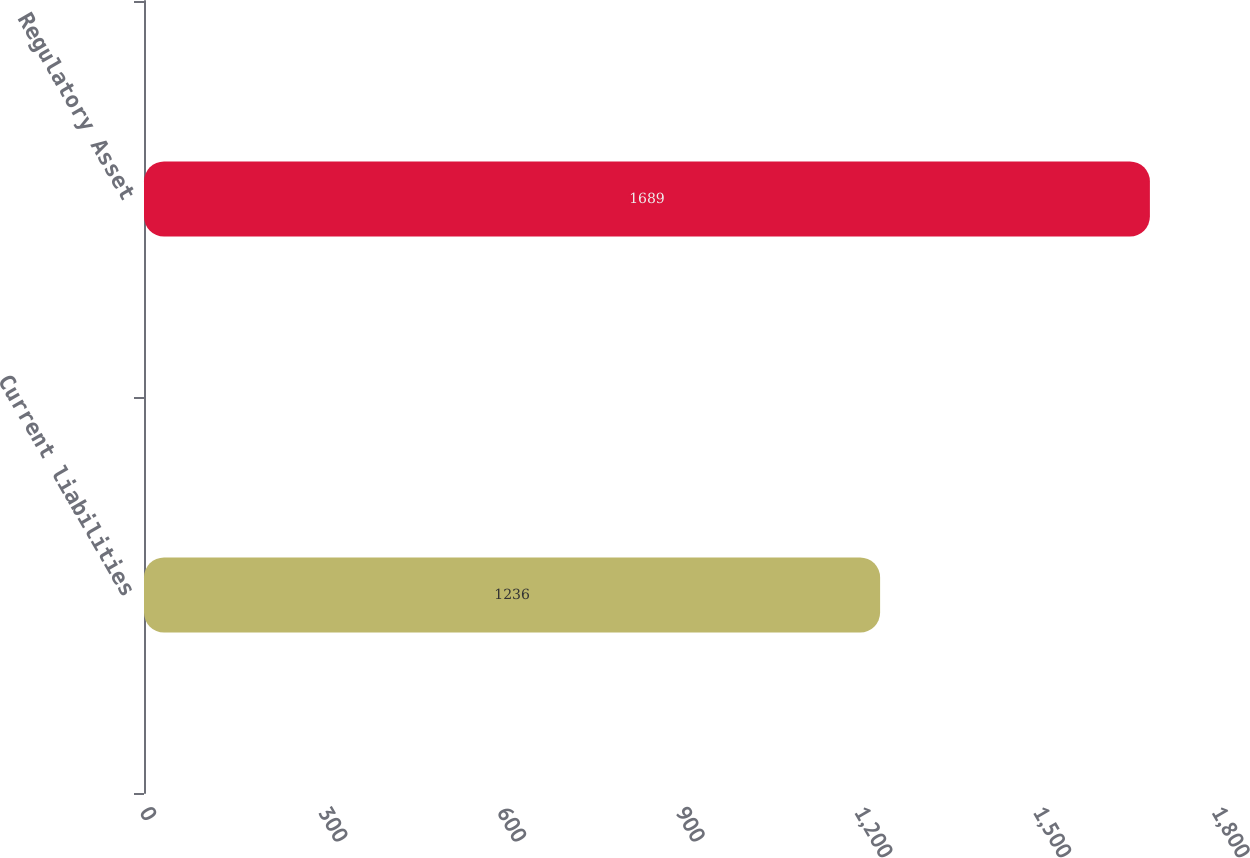Convert chart to OTSL. <chart><loc_0><loc_0><loc_500><loc_500><bar_chart><fcel>Current liabilities<fcel>Regulatory Asset<nl><fcel>1236<fcel>1689<nl></chart> 